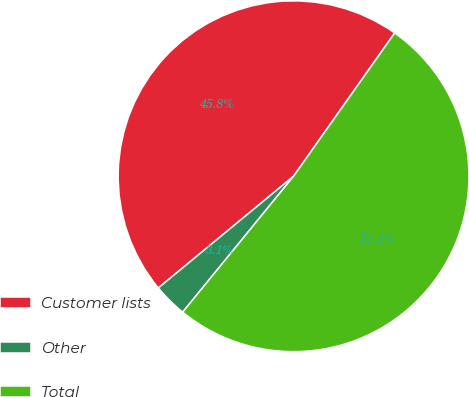<chart> <loc_0><loc_0><loc_500><loc_500><pie_chart><fcel>Customer lists<fcel>Other<fcel>Total<nl><fcel>45.77%<fcel>3.12%<fcel>51.11%<nl></chart> 